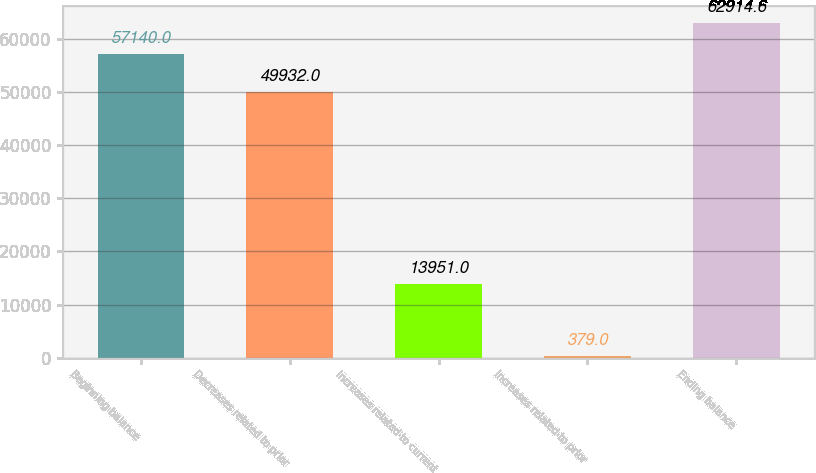Convert chart to OTSL. <chart><loc_0><loc_0><loc_500><loc_500><bar_chart><fcel>Beginning balance<fcel>Decreases related to prior<fcel>Increases related to current<fcel>Increases related to prior<fcel>Ending balance<nl><fcel>57140<fcel>49932<fcel>13951<fcel>379<fcel>62914.6<nl></chart> 